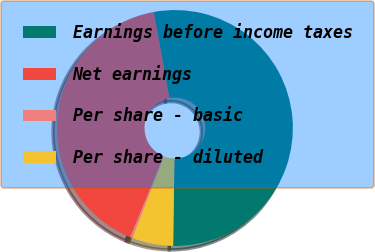Convert chart. <chart><loc_0><loc_0><loc_500><loc_500><pie_chart><fcel>Earnings before income taxes<fcel>Net earnings<fcel>Per share - basic<fcel>Per share - diluted<nl><fcel>53.1%<fcel>40.9%<fcel>0.36%<fcel>5.63%<nl></chart> 